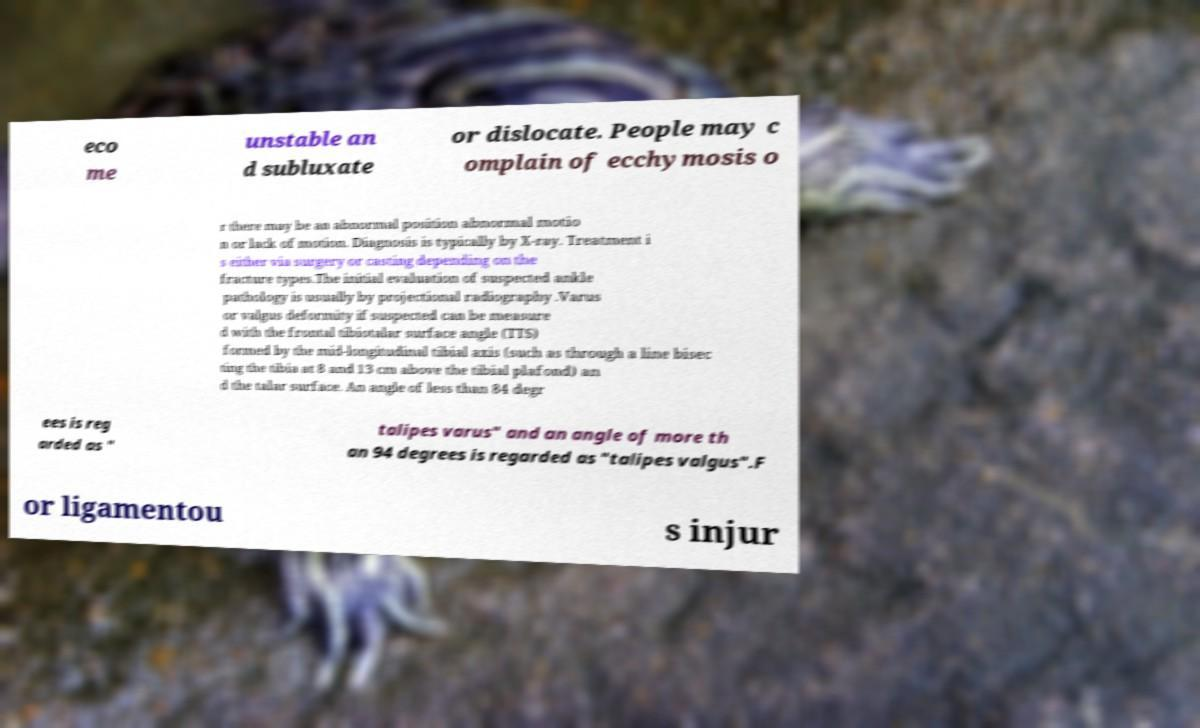Please read and relay the text visible in this image. What does it say? eco me unstable an d subluxate or dislocate. People may c omplain of ecchymosis o r there may be an abnormal position abnormal motio n or lack of motion. Diagnosis is typically by X-ray. Treatment i s either via surgery or casting depending on the fracture types.The initial evaluation of suspected ankle pathology is usually by projectional radiography .Varus or valgus deformity if suspected can be measure d with the frontal tibiotalar surface angle (TTS) formed by the mid-longitudinal tibial axis (such as through a line bisec ting the tibia at 8 and 13 cm above the tibial plafond) an d the talar surface. An angle of less than 84 degr ees is reg arded as " talipes varus" and an angle of more th an 94 degrees is regarded as "talipes valgus".F or ligamentou s injur 